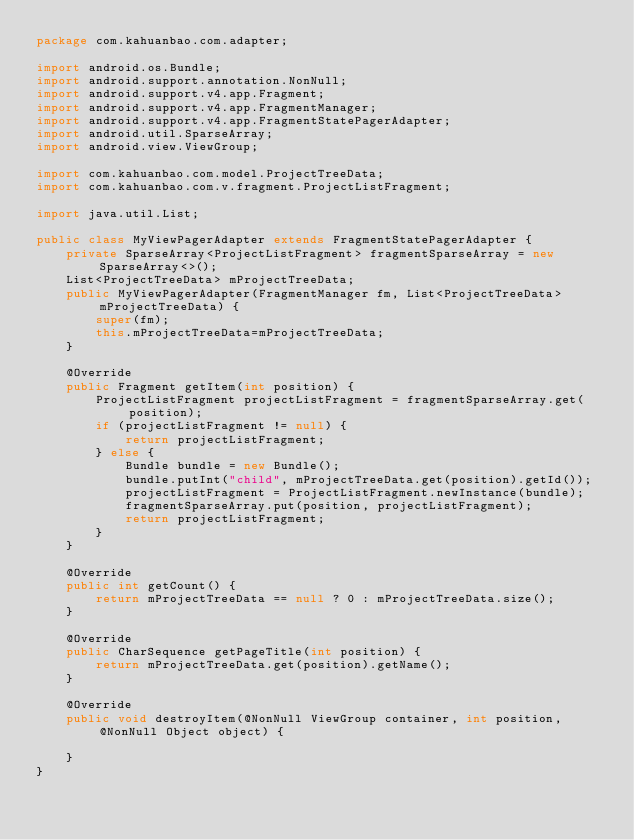Convert code to text. <code><loc_0><loc_0><loc_500><loc_500><_Java_>package com.kahuanbao.com.adapter;

import android.os.Bundle;
import android.support.annotation.NonNull;
import android.support.v4.app.Fragment;
import android.support.v4.app.FragmentManager;
import android.support.v4.app.FragmentStatePagerAdapter;
import android.util.SparseArray;
import android.view.ViewGroup;

import com.kahuanbao.com.model.ProjectTreeData;
import com.kahuanbao.com.v.fragment.ProjectListFragment;

import java.util.List;

public class MyViewPagerAdapter extends FragmentStatePagerAdapter {
    private SparseArray<ProjectListFragment> fragmentSparseArray = new SparseArray<>();
    List<ProjectTreeData> mProjectTreeData;
    public MyViewPagerAdapter(FragmentManager fm, List<ProjectTreeData> mProjectTreeData) {
        super(fm);
        this.mProjectTreeData=mProjectTreeData;
    }

    @Override
    public Fragment getItem(int position) {
        ProjectListFragment projectListFragment = fragmentSparseArray.get(position);
        if (projectListFragment != null) {
            return projectListFragment;
        } else {
            Bundle bundle = new Bundle();
            bundle.putInt("child", mProjectTreeData.get(position).getId());
            projectListFragment = ProjectListFragment.newInstance(bundle);
            fragmentSparseArray.put(position, projectListFragment);
            return projectListFragment;
        }
    }

    @Override
    public int getCount() {
        return mProjectTreeData == null ? 0 : mProjectTreeData.size();
    }

    @Override
    public CharSequence getPageTitle(int position) {
        return mProjectTreeData.get(position).getName();
    }

    @Override
    public void destroyItem(@NonNull ViewGroup container, int position, @NonNull Object object) {

    }
}
</code> 